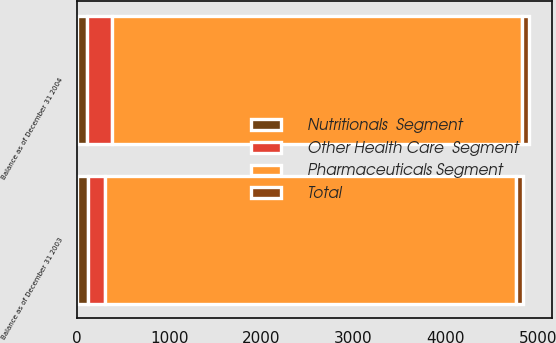Convert chart. <chart><loc_0><loc_0><loc_500><loc_500><stacked_bar_chart><ecel><fcel>Balance as of December 31 2003<fcel>Balance as of December 31 2004<nl><fcel>Pharmaceuticals Segment<fcel>4448<fcel>4448<nl><fcel>Nutritionals  Segment<fcel>118<fcel>113<nl><fcel>Other Health Care  Segment<fcel>190<fcel>264<nl><fcel>Total<fcel>80<fcel>80<nl></chart> 